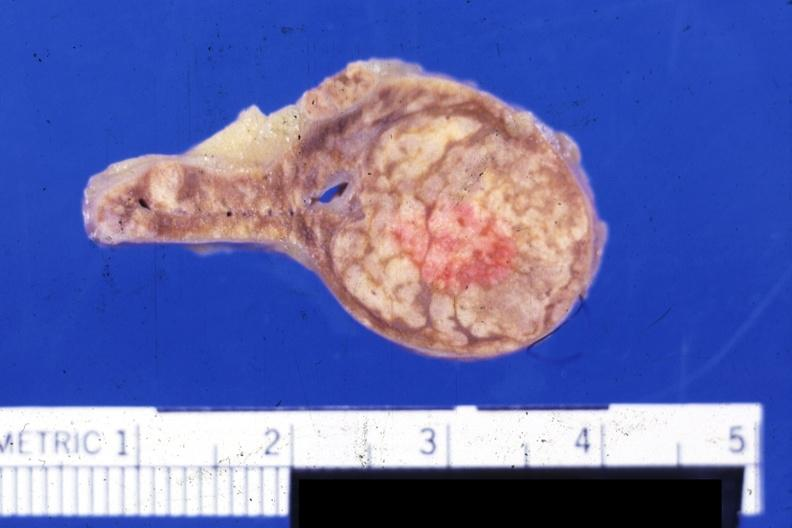s endocrine present?
Answer the question using a single word or phrase. Yes 